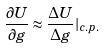Convert formula to latex. <formula><loc_0><loc_0><loc_500><loc_500>\frac { \partial U } { \partial g } \approx \frac { \Delta U } { \Delta g } | _ { c . p . }</formula> 